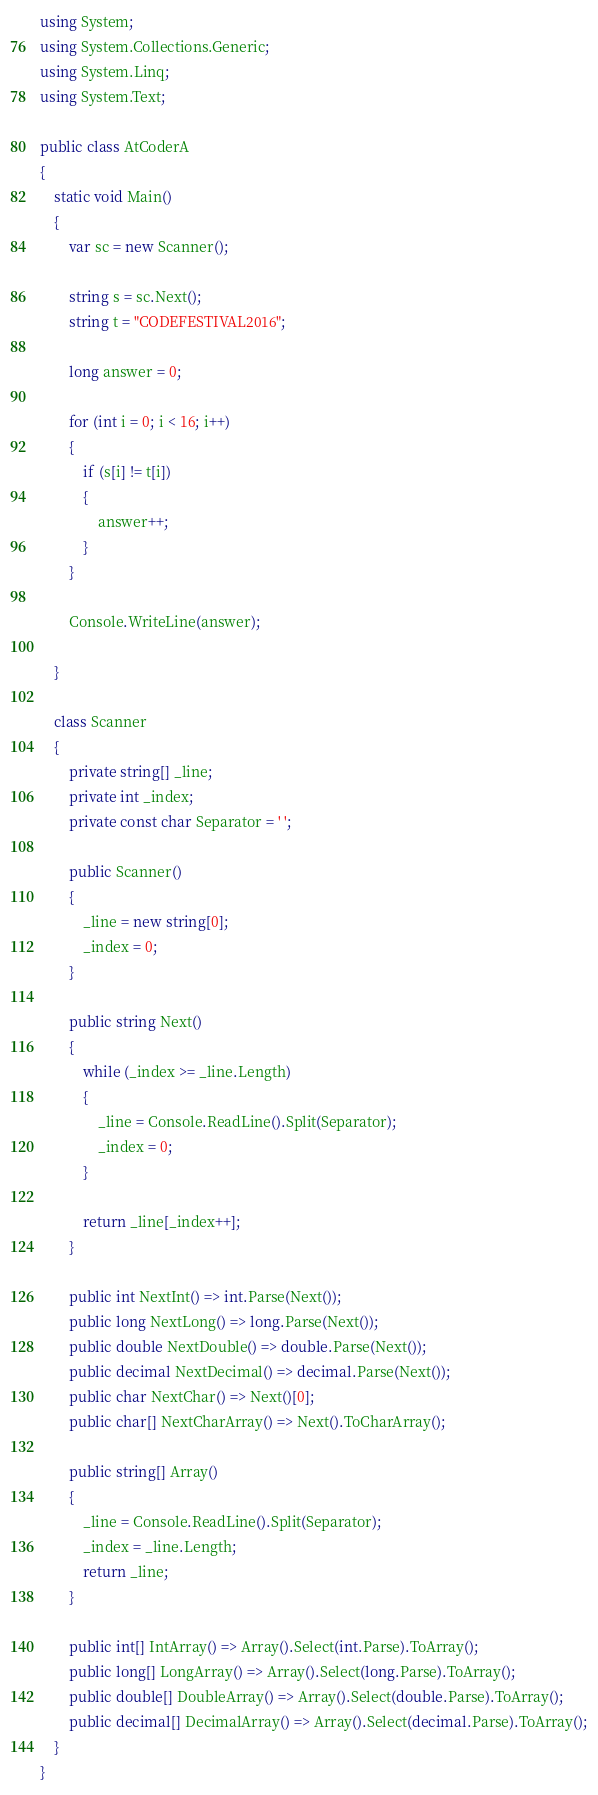Convert code to text. <code><loc_0><loc_0><loc_500><loc_500><_C#_>using System;
using System.Collections.Generic;
using System.Linq;
using System.Text;

public class AtCoderA
{
    static void Main()
    {
        var sc = new Scanner();

        string s = sc.Next();
        string t = "CODEFESTIVAL2016";

        long answer = 0;

        for (int i = 0; i < 16; i++)
        {
            if (s[i] != t[i])
            {
                answer++;
            }
        }

        Console.WriteLine(answer);

    }

    class Scanner
    {
        private string[] _line;
        private int _index;
        private const char Separator = ' ';

        public Scanner()
        {
            _line = new string[0];
            _index = 0;
        }

        public string Next()
        {
            while (_index >= _line.Length)
            {
                _line = Console.ReadLine().Split(Separator);
                _index = 0;
            }

            return _line[_index++];
        }

        public int NextInt() => int.Parse(Next());
        public long NextLong() => long.Parse(Next());
        public double NextDouble() => double.Parse(Next());
        public decimal NextDecimal() => decimal.Parse(Next());
        public char NextChar() => Next()[0];
        public char[] NextCharArray() => Next().ToCharArray();

        public string[] Array()
        {
            _line = Console.ReadLine().Split(Separator);
            _index = _line.Length;
            return _line;
        }

        public int[] IntArray() => Array().Select(int.Parse).ToArray();
        public long[] LongArray() => Array().Select(long.Parse).ToArray();
        public double[] DoubleArray() => Array().Select(double.Parse).ToArray();
        public decimal[] DecimalArray() => Array().Select(decimal.Parse).ToArray();
    }
}
</code> 